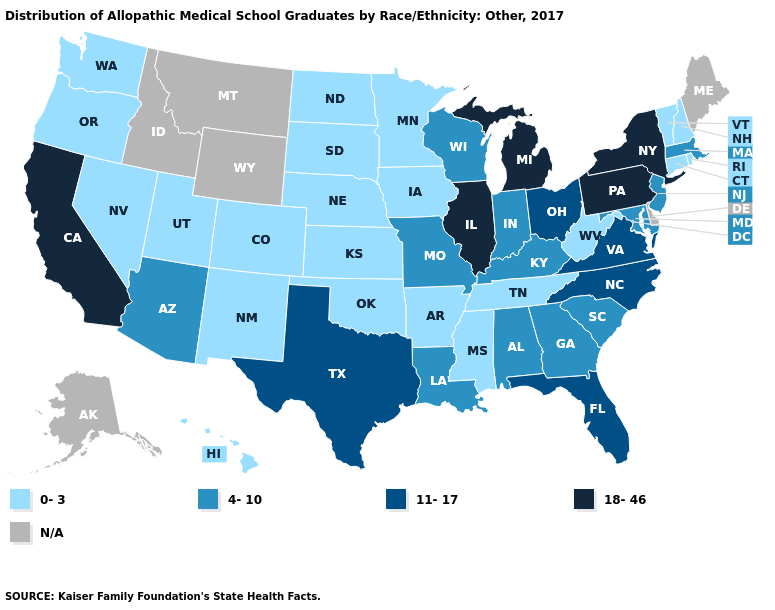Among the states that border Louisiana , which have the highest value?
Give a very brief answer. Texas. What is the highest value in states that border Tennessee?
Write a very short answer. 11-17. How many symbols are there in the legend?
Concise answer only. 5. What is the highest value in the Northeast ?
Concise answer only. 18-46. What is the value of Alaska?
Quick response, please. N/A. Name the states that have a value in the range 18-46?
Write a very short answer. California, Illinois, Michigan, New York, Pennsylvania. What is the value of South Dakota?
Quick response, please. 0-3. What is the value of Oregon?
Keep it brief. 0-3. What is the value of New Mexico?
Keep it brief. 0-3. Name the states that have a value in the range 18-46?
Short answer required. California, Illinois, Michigan, New York, Pennsylvania. What is the value of Connecticut?
Answer briefly. 0-3. Does New Hampshire have the lowest value in the USA?
Quick response, please. Yes. What is the value of Nevada?
Give a very brief answer. 0-3. Name the states that have a value in the range N/A?
Answer briefly. Alaska, Delaware, Idaho, Maine, Montana, Wyoming. 